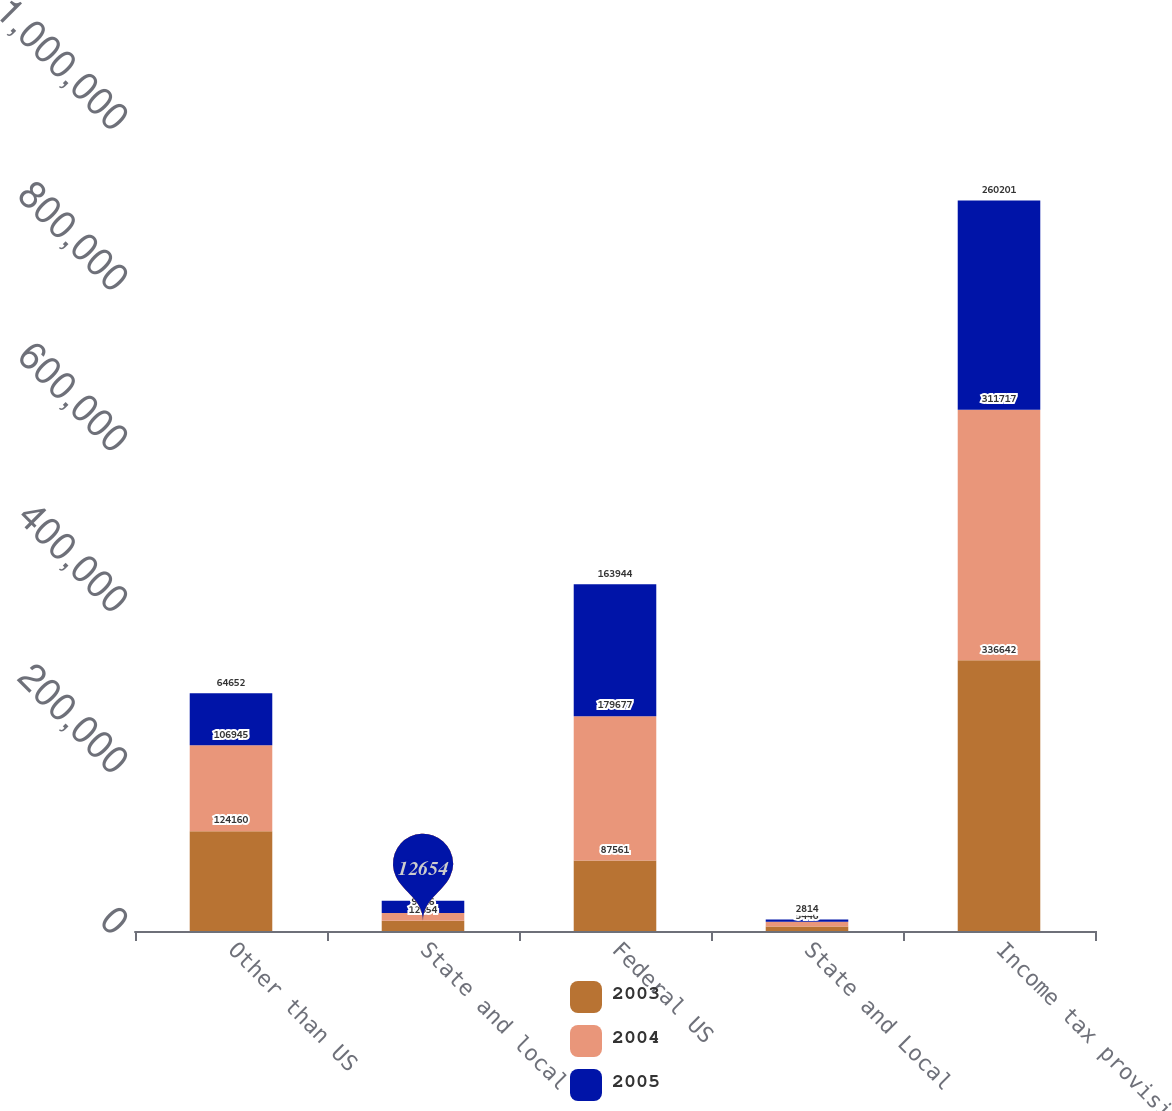Convert chart. <chart><loc_0><loc_0><loc_500><loc_500><stacked_bar_chart><ecel><fcel>Other than US<fcel>State and local<fcel>Federal US<fcel>State and Local<fcel>Income tax provision<nl><fcel>2003<fcel>124160<fcel>12654<fcel>87561<fcel>5446<fcel>336642<nl><fcel>2004<fcel>106945<fcel>9816<fcel>179677<fcel>5984<fcel>311717<nl><fcel>2005<fcel>64652<fcel>15186<fcel>163944<fcel>2814<fcel>260201<nl></chart> 